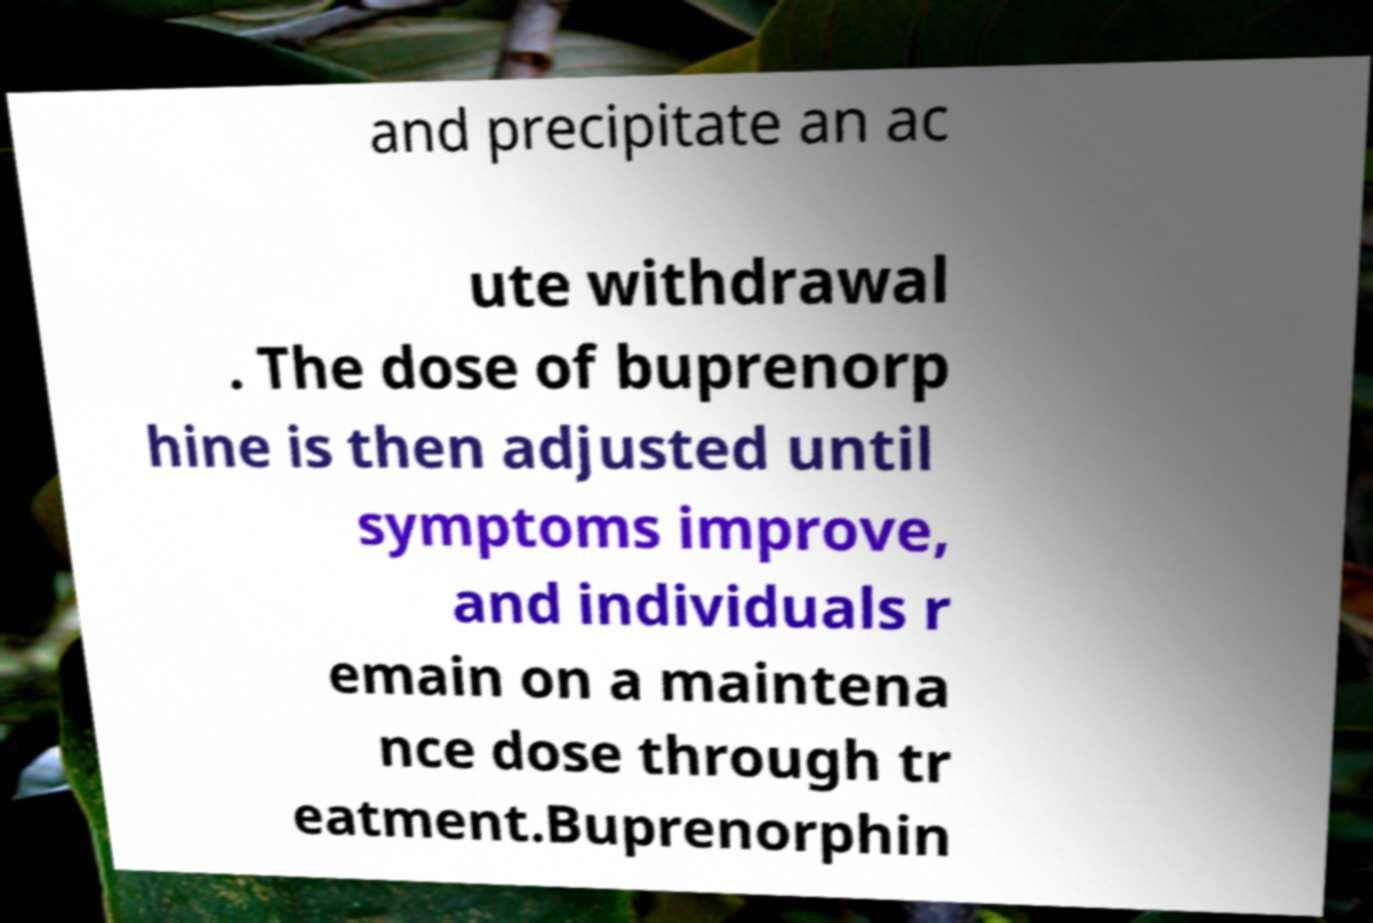Please read and relay the text visible in this image. What does it say? and precipitate an ac ute withdrawal . The dose of buprenorp hine is then adjusted until symptoms improve, and individuals r emain on a maintena nce dose through tr eatment.Buprenorphin 